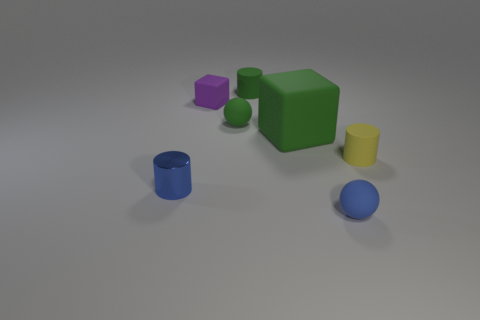Are there any other things that are the same material as the blue cylinder?
Offer a terse response. No. What is the material of the cylinder that is the same color as the large rubber thing?
Your response must be concise. Rubber. What number of objects are either things that are in front of the large green rubber block or small cyan shiny objects?
Make the answer very short. 3. How many small blue objects are to the left of the block behind the matte cube that is right of the tiny green cylinder?
Offer a terse response. 1. Are there any other things that have the same size as the yellow rubber cylinder?
Provide a succinct answer. Yes. The blue thing on the left side of the small matte cylinder behind the rubber sphere that is behind the blue matte thing is what shape?
Keep it short and to the point. Cylinder. How many other things are the same color as the large matte thing?
Keep it short and to the point. 2. What is the shape of the object behind the purple block that is on the left side of the small green cylinder?
Keep it short and to the point. Cylinder. What number of tiny blue things are left of the small blue rubber sphere?
Make the answer very short. 1. Are there any cylinders made of the same material as the large green object?
Offer a terse response. Yes. 